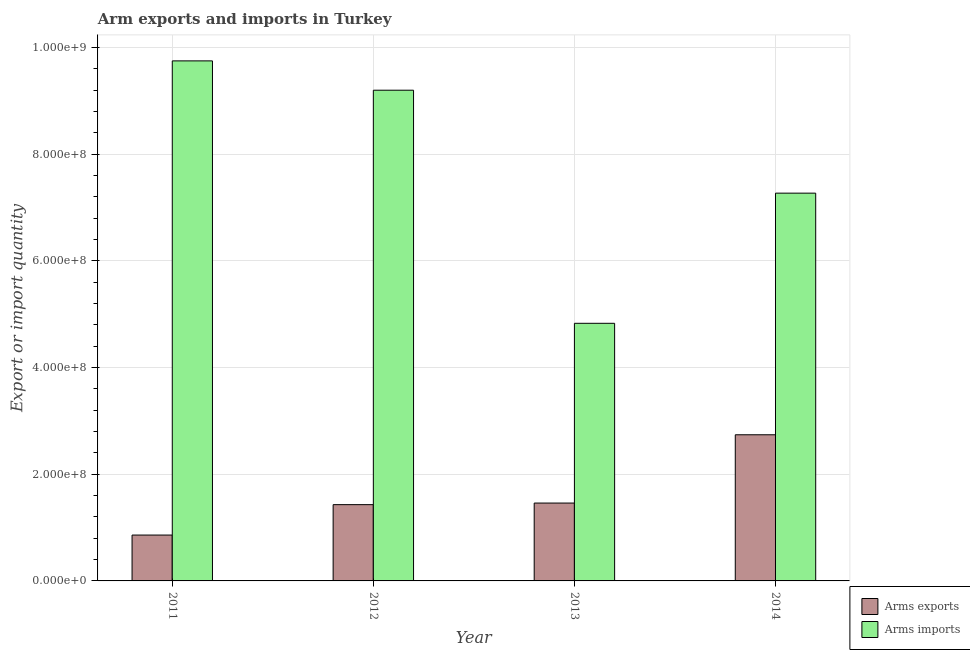How many different coloured bars are there?
Offer a very short reply. 2. How many groups of bars are there?
Provide a short and direct response. 4. How many bars are there on the 2nd tick from the right?
Offer a very short reply. 2. What is the arms exports in 2011?
Provide a short and direct response. 8.60e+07. Across all years, what is the maximum arms exports?
Make the answer very short. 2.74e+08. Across all years, what is the minimum arms exports?
Provide a short and direct response. 8.60e+07. In which year was the arms imports maximum?
Keep it short and to the point. 2011. What is the total arms imports in the graph?
Make the answer very short. 3.10e+09. What is the difference between the arms imports in 2012 and that in 2013?
Offer a terse response. 4.37e+08. What is the difference between the arms imports in 2012 and the arms exports in 2014?
Make the answer very short. 1.93e+08. What is the average arms imports per year?
Your answer should be very brief. 7.76e+08. In how many years, is the arms exports greater than 720000000?
Make the answer very short. 0. What is the ratio of the arms exports in 2011 to that in 2013?
Ensure brevity in your answer.  0.59. Is the difference between the arms exports in 2011 and 2012 greater than the difference between the arms imports in 2011 and 2012?
Keep it short and to the point. No. What is the difference between the highest and the second highest arms imports?
Give a very brief answer. 5.50e+07. What is the difference between the highest and the lowest arms exports?
Your response must be concise. 1.88e+08. In how many years, is the arms exports greater than the average arms exports taken over all years?
Your response must be concise. 1. Is the sum of the arms imports in 2013 and 2014 greater than the maximum arms exports across all years?
Give a very brief answer. Yes. What does the 1st bar from the left in 2012 represents?
Your answer should be very brief. Arms exports. What does the 2nd bar from the right in 2011 represents?
Provide a succinct answer. Arms exports. Are all the bars in the graph horizontal?
Keep it short and to the point. No. What is the difference between two consecutive major ticks on the Y-axis?
Make the answer very short. 2.00e+08. Does the graph contain any zero values?
Give a very brief answer. No. Does the graph contain grids?
Make the answer very short. Yes. How many legend labels are there?
Make the answer very short. 2. What is the title of the graph?
Offer a terse response. Arm exports and imports in Turkey. Does "Taxes on profits and capital gains" appear as one of the legend labels in the graph?
Offer a very short reply. No. What is the label or title of the Y-axis?
Give a very brief answer. Export or import quantity. What is the Export or import quantity in Arms exports in 2011?
Keep it short and to the point. 8.60e+07. What is the Export or import quantity in Arms imports in 2011?
Keep it short and to the point. 9.75e+08. What is the Export or import quantity of Arms exports in 2012?
Keep it short and to the point. 1.43e+08. What is the Export or import quantity in Arms imports in 2012?
Ensure brevity in your answer.  9.20e+08. What is the Export or import quantity of Arms exports in 2013?
Give a very brief answer. 1.46e+08. What is the Export or import quantity of Arms imports in 2013?
Offer a very short reply. 4.83e+08. What is the Export or import quantity in Arms exports in 2014?
Offer a very short reply. 2.74e+08. What is the Export or import quantity in Arms imports in 2014?
Give a very brief answer. 7.27e+08. Across all years, what is the maximum Export or import quantity of Arms exports?
Offer a terse response. 2.74e+08. Across all years, what is the maximum Export or import quantity in Arms imports?
Offer a terse response. 9.75e+08. Across all years, what is the minimum Export or import quantity of Arms exports?
Offer a very short reply. 8.60e+07. Across all years, what is the minimum Export or import quantity of Arms imports?
Provide a succinct answer. 4.83e+08. What is the total Export or import quantity in Arms exports in the graph?
Your answer should be compact. 6.49e+08. What is the total Export or import quantity in Arms imports in the graph?
Your answer should be compact. 3.10e+09. What is the difference between the Export or import quantity of Arms exports in 2011 and that in 2012?
Make the answer very short. -5.70e+07. What is the difference between the Export or import quantity in Arms imports in 2011 and that in 2012?
Provide a succinct answer. 5.50e+07. What is the difference between the Export or import quantity in Arms exports in 2011 and that in 2013?
Give a very brief answer. -6.00e+07. What is the difference between the Export or import quantity of Arms imports in 2011 and that in 2013?
Provide a short and direct response. 4.92e+08. What is the difference between the Export or import quantity of Arms exports in 2011 and that in 2014?
Your answer should be very brief. -1.88e+08. What is the difference between the Export or import quantity in Arms imports in 2011 and that in 2014?
Keep it short and to the point. 2.48e+08. What is the difference between the Export or import quantity in Arms imports in 2012 and that in 2013?
Keep it short and to the point. 4.37e+08. What is the difference between the Export or import quantity in Arms exports in 2012 and that in 2014?
Make the answer very short. -1.31e+08. What is the difference between the Export or import quantity in Arms imports in 2012 and that in 2014?
Offer a terse response. 1.93e+08. What is the difference between the Export or import quantity of Arms exports in 2013 and that in 2014?
Provide a succinct answer. -1.28e+08. What is the difference between the Export or import quantity in Arms imports in 2013 and that in 2014?
Ensure brevity in your answer.  -2.44e+08. What is the difference between the Export or import quantity in Arms exports in 2011 and the Export or import quantity in Arms imports in 2012?
Provide a succinct answer. -8.34e+08. What is the difference between the Export or import quantity of Arms exports in 2011 and the Export or import quantity of Arms imports in 2013?
Ensure brevity in your answer.  -3.97e+08. What is the difference between the Export or import quantity of Arms exports in 2011 and the Export or import quantity of Arms imports in 2014?
Provide a succinct answer. -6.41e+08. What is the difference between the Export or import quantity of Arms exports in 2012 and the Export or import quantity of Arms imports in 2013?
Give a very brief answer. -3.40e+08. What is the difference between the Export or import quantity in Arms exports in 2012 and the Export or import quantity in Arms imports in 2014?
Keep it short and to the point. -5.84e+08. What is the difference between the Export or import quantity in Arms exports in 2013 and the Export or import quantity in Arms imports in 2014?
Make the answer very short. -5.81e+08. What is the average Export or import quantity in Arms exports per year?
Give a very brief answer. 1.62e+08. What is the average Export or import quantity in Arms imports per year?
Give a very brief answer. 7.76e+08. In the year 2011, what is the difference between the Export or import quantity of Arms exports and Export or import quantity of Arms imports?
Give a very brief answer. -8.89e+08. In the year 2012, what is the difference between the Export or import quantity of Arms exports and Export or import quantity of Arms imports?
Offer a terse response. -7.77e+08. In the year 2013, what is the difference between the Export or import quantity of Arms exports and Export or import quantity of Arms imports?
Your answer should be compact. -3.37e+08. In the year 2014, what is the difference between the Export or import quantity in Arms exports and Export or import quantity in Arms imports?
Make the answer very short. -4.53e+08. What is the ratio of the Export or import quantity in Arms exports in 2011 to that in 2012?
Offer a terse response. 0.6. What is the ratio of the Export or import quantity of Arms imports in 2011 to that in 2012?
Your answer should be very brief. 1.06. What is the ratio of the Export or import quantity of Arms exports in 2011 to that in 2013?
Offer a terse response. 0.59. What is the ratio of the Export or import quantity in Arms imports in 2011 to that in 2013?
Provide a succinct answer. 2.02. What is the ratio of the Export or import quantity in Arms exports in 2011 to that in 2014?
Your answer should be very brief. 0.31. What is the ratio of the Export or import quantity of Arms imports in 2011 to that in 2014?
Your answer should be compact. 1.34. What is the ratio of the Export or import quantity in Arms exports in 2012 to that in 2013?
Make the answer very short. 0.98. What is the ratio of the Export or import quantity in Arms imports in 2012 to that in 2013?
Your answer should be very brief. 1.9. What is the ratio of the Export or import quantity in Arms exports in 2012 to that in 2014?
Provide a short and direct response. 0.52. What is the ratio of the Export or import quantity in Arms imports in 2012 to that in 2014?
Your response must be concise. 1.27. What is the ratio of the Export or import quantity in Arms exports in 2013 to that in 2014?
Provide a short and direct response. 0.53. What is the ratio of the Export or import quantity of Arms imports in 2013 to that in 2014?
Ensure brevity in your answer.  0.66. What is the difference between the highest and the second highest Export or import quantity in Arms exports?
Your answer should be very brief. 1.28e+08. What is the difference between the highest and the second highest Export or import quantity of Arms imports?
Ensure brevity in your answer.  5.50e+07. What is the difference between the highest and the lowest Export or import quantity of Arms exports?
Ensure brevity in your answer.  1.88e+08. What is the difference between the highest and the lowest Export or import quantity in Arms imports?
Ensure brevity in your answer.  4.92e+08. 